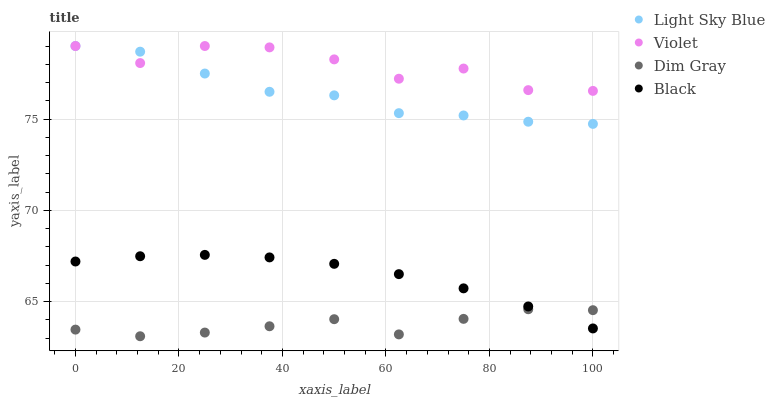Does Dim Gray have the minimum area under the curve?
Answer yes or no. Yes. Does Violet have the maximum area under the curve?
Answer yes or no. Yes. Does Light Sky Blue have the minimum area under the curve?
Answer yes or no. No. Does Light Sky Blue have the maximum area under the curve?
Answer yes or no. No. Is Black the smoothest?
Answer yes or no. Yes. Is Violet the roughest?
Answer yes or no. Yes. Is Light Sky Blue the smoothest?
Answer yes or no. No. Is Light Sky Blue the roughest?
Answer yes or no. No. Does Dim Gray have the lowest value?
Answer yes or no. Yes. Does Light Sky Blue have the lowest value?
Answer yes or no. No. Does Violet have the highest value?
Answer yes or no. Yes. Does Black have the highest value?
Answer yes or no. No. Is Black less than Violet?
Answer yes or no. Yes. Is Violet greater than Dim Gray?
Answer yes or no. Yes. Does Dim Gray intersect Black?
Answer yes or no. Yes. Is Dim Gray less than Black?
Answer yes or no. No. Is Dim Gray greater than Black?
Answer yes or no. No. Does Black intersect Violet?
Answer yes or no. No. 